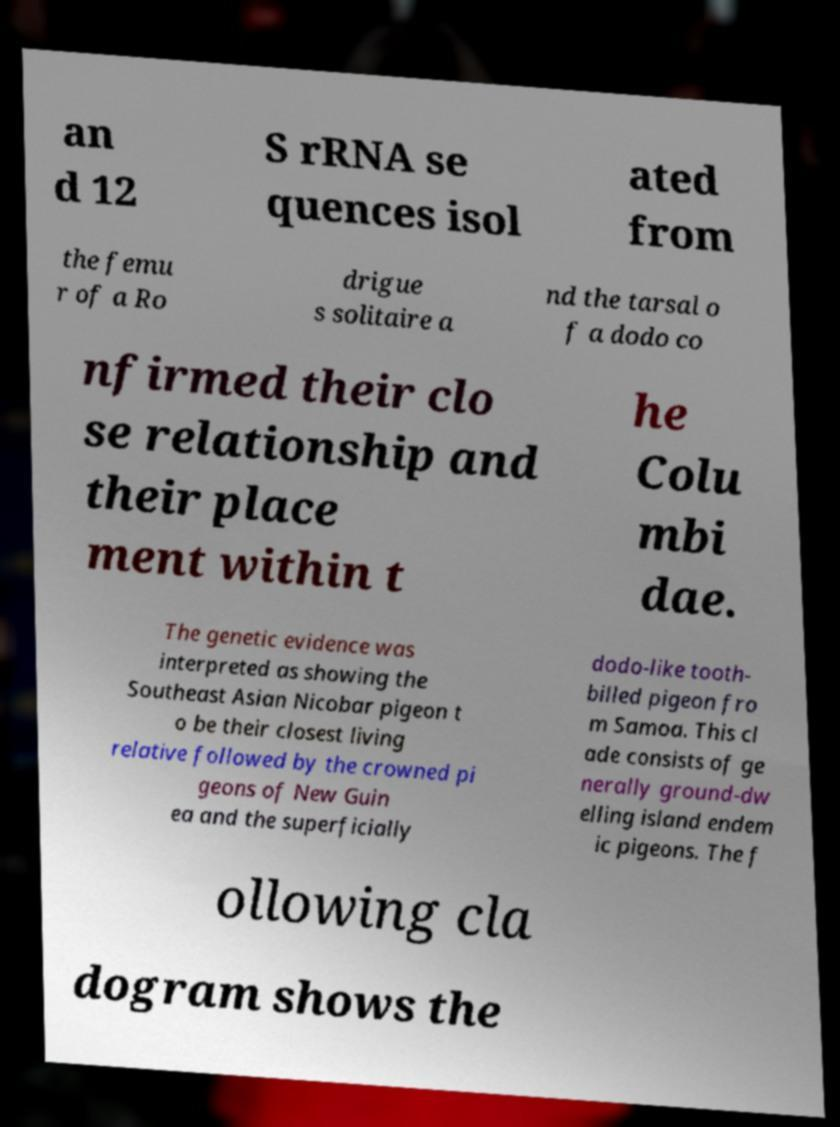Could you assist in decoding the text presented in this image and type it out clearly? an d 12 S rRNA se quences isol ated from the femu r of a Ro drigue s solitaire a nd the tarsal o f a dodo co nfirmed their clo se relationship and their place ment within t he Colu mbi dae. The genetic evidence was interpreted as showing the Southeast Asian Nicobar pigeon t o be their closest living relative followed by the crowned pi geons of New Guin ea and the superficially dodo-like tooth- billed pigeon fro m Samoa. This cl ade consists of ge nerally ground-dw elling island endem ic pigeons. The f ollowing cla dogram shows the 